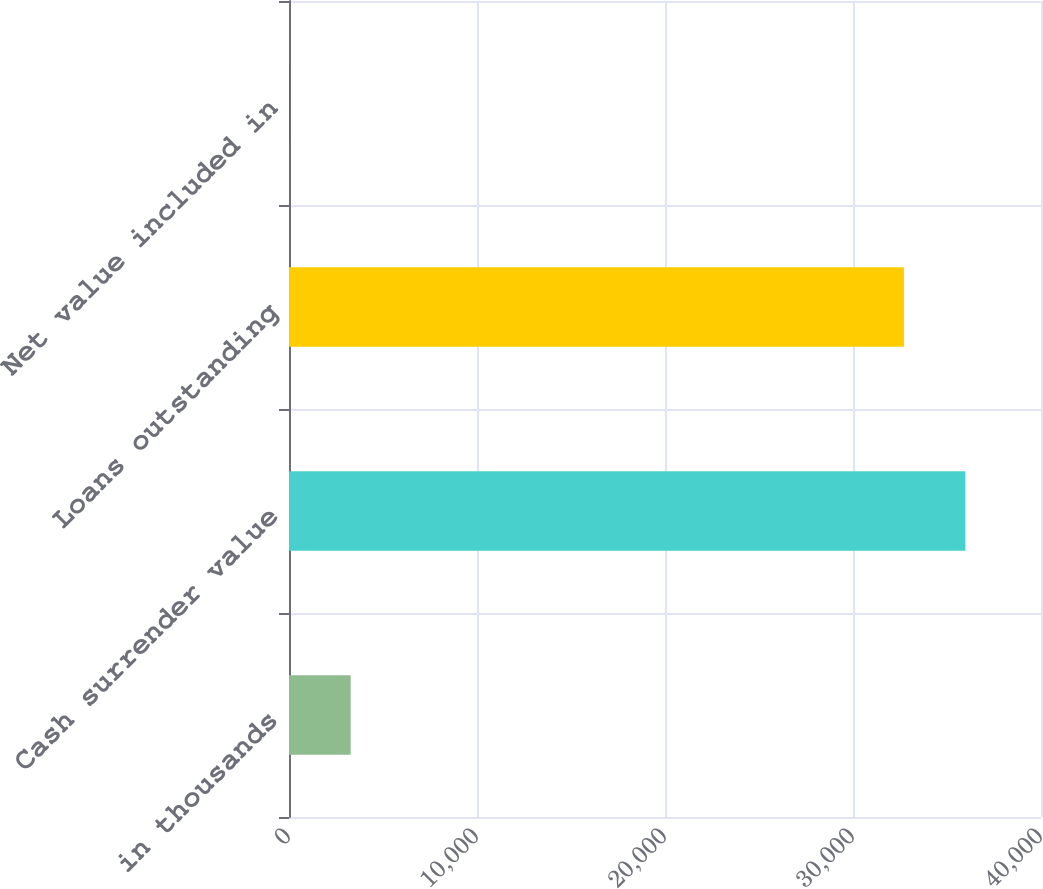<chart> <loc_0><loc_0><loc_500><loc_500><bar_chart><fcel>in thousands<fcel>Cash surrender value<fcel>Loans outstanding<fcel>Net value included in<nl><fcel>3281<fcel>35981<fcel>32710<fcel>10<nl></chart> 